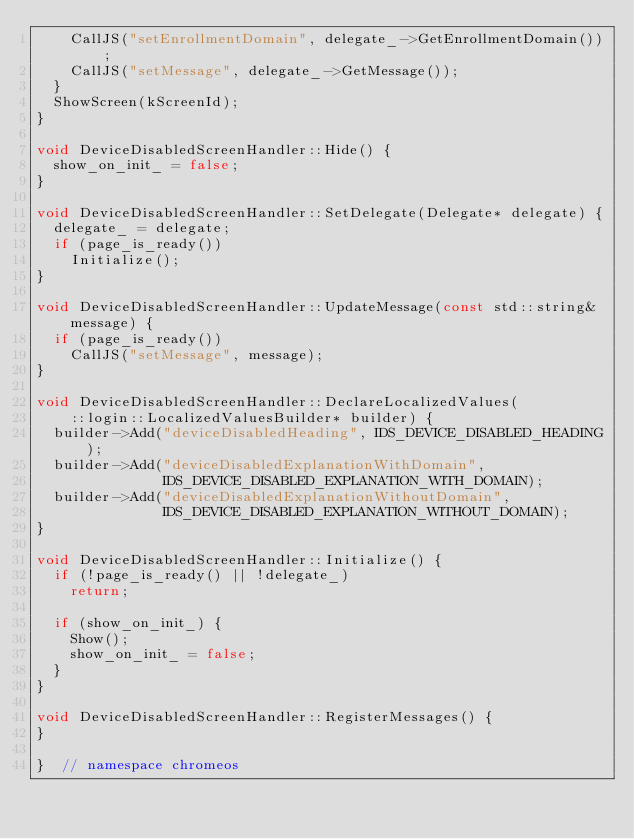<code> <loc_0><loc_0><loc_500><loc_500><_C++_>    CallJS("setEnrollmentDomain", delegate_->GetEnrollmentDomain());
    CallJS("setMessage", delegate_->GetMessage());
  }
  ShowScreen(kScreenId);
}

void DeviceDisabledScreenHandler::Hide() {
  show_on_init_ = false;
}

void DeviceDisabledScreenHandler::SetDelegate(Delegate* delegate) {
  delegate_ = delegate;
  if (page_is_ready())
    Initialize();
}

void DeviceDisabledScreenHandler::UpdateMessage(const std::string& message) {
  if (page_is_ready())
    CallJS("setMessage", message);
}

void DeviceDisabledScreenHandler::DeclareLocalizedValues(
    ::login::LocalizedValuesBuilder* builder) {
  builder->Add("deviceDisabledHeading", IDS_DEVICE_DISABLED_HEADING);
  builder->Add("deviceDisabledExplanationWithDomain",
               IDS_DEVICE_DISABLED_EXPLANATION_WITH_DOMAIN);
  builder->Add("deviceDisabledExplanationWithoutDomain",
               IDS_DEVICE_DISABLED_EXPLANATION_WITHOUT_DOMAIN);
}

void DeviceDisabledScreenHandler::Initialize() {
  if (!page_is_ready() || !delegate_)
    return;

  if (show_on_init_) {
    Show();
    show_on_init_ = false;
  }
}

void DeviceDisabledScreenHandler::RegisterMessages() {
}

}  // namespace chromeos
</code> 